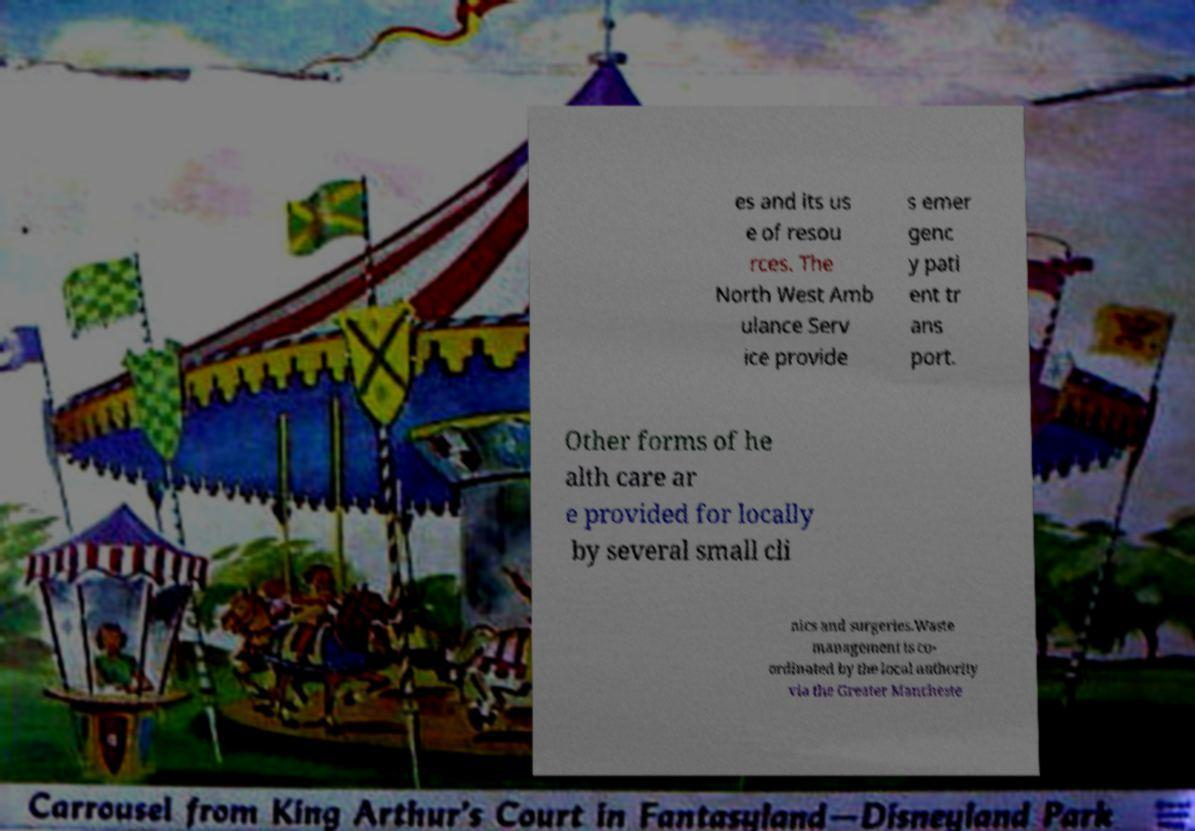For documentation purposes, I need the text within this image transcribed. Could you provide that? es and its us e of resou rces. The North West Amb ulance Serv ice provide s emer genc y pati ent tr ans port. Other forms of he alth care ar e provided for locally by several small cli nics and surgeries.Waste management is co- ordinated by the local authority via the Greater Mancheste 